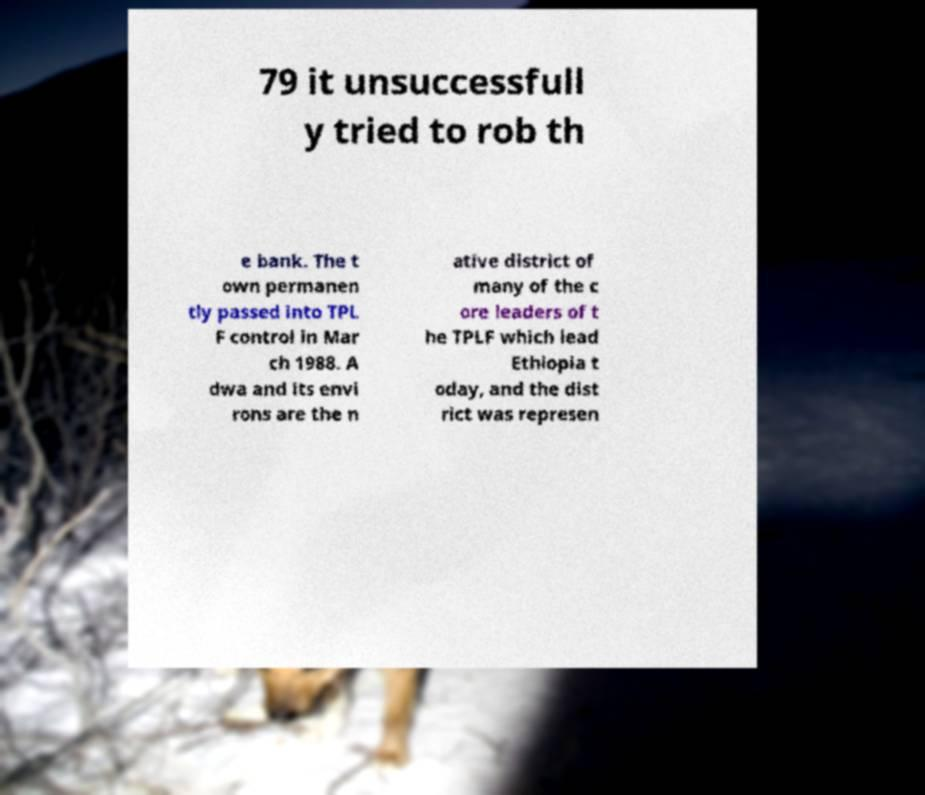Can you read and provide the text displayed in the image?This photo seems to have some interesting text. Can you extract and type it out for me? 79 it unsuccessfull y tried to rob th e bank. The t own permanen tly passed into TPL F control in Mar ch 1988. A dwa and its envi rons are the n ative district of many of the c ore leaders of t he TPLF which lead Ethiopia t oday, and the dist rict was represen 